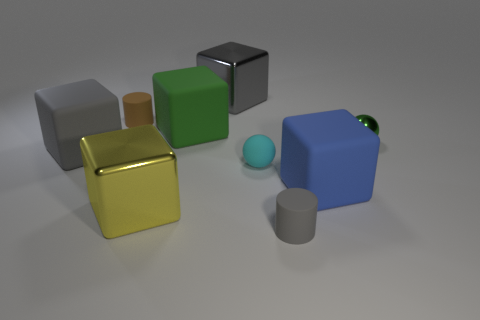Is the size of the shiny ball the same as the cylinder behind the big green thing?
Ensure brevity in your answer.  Yes. The yellow thing that is the same shape as the large gray rubber thing is what size?
Make the answer very short. Large. Is there any other thing that has the same material as the brown thing?
Give a very brief answer. Yes. Do the cube to the left of the yellow thing and the rubber block that is in front of the small cyan sphere have the same size?
Your answer should be compact. Yes. How many tiny objects are either objects or matte blocks?
Your response must be concise. 4. How many tiny objects are both in front of the gray rubber block and behind the gray rubber cylinder?
Give a very brief answer. 1. Is the material of the large green cube the same as the gray cube in front of the small green metal thing?
Offer a terse response. Yes. How many brown things are rubber things or large blocks?
Your answer should be compact. 1. Is there another gray thing of the same size as the gray metallic object?
Offer a very short reply. Yes. What is the material of the cylinder to the right of the matte cylinder left of the small cylinder right of the brown matte cylinder?
Your response must be concise. Rubber. 